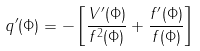<formula> <loc_0><loc_0><loc_500><loc_500>q ^ { \prime } ( \Phi ) = - \left [ \frac { V ^ { \prime } ( \Phi ) } { f ^ { 2 } ( \Phi ) } + \frac { f ^ { \prime } ( \Phi ) } { f ( \Phi ) } \right ]</formula> 